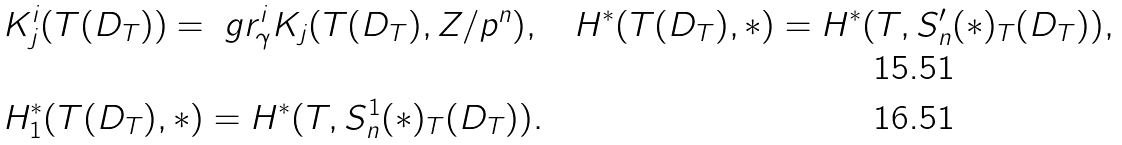Convert formula to latex. <formula><loc_0><loc_0><loc_500><loc_500>& K ^ { i } _ { j } ( T ( D _ { T } ) ) = \ g r ^ { i } _ { \gamma } K _ { j } ( T ( D _ { T } ) , Z / p ^ { n } ) , \quad H ^ { * } ( T ( D _ { T } ) , * ) = H ^ { * } ( T , S ^ { \prime } _ { n } ( * ) _ { T } ( D _ { T } ) ) , \\ & H ^ { * } _ { 1 } ( T ( D _ { T } ) , * ) = H ^ { * } ( T , S ^ { 1 } _ { n } ( * ) _ { T } ( D _ { T } ) ) .</formula> 